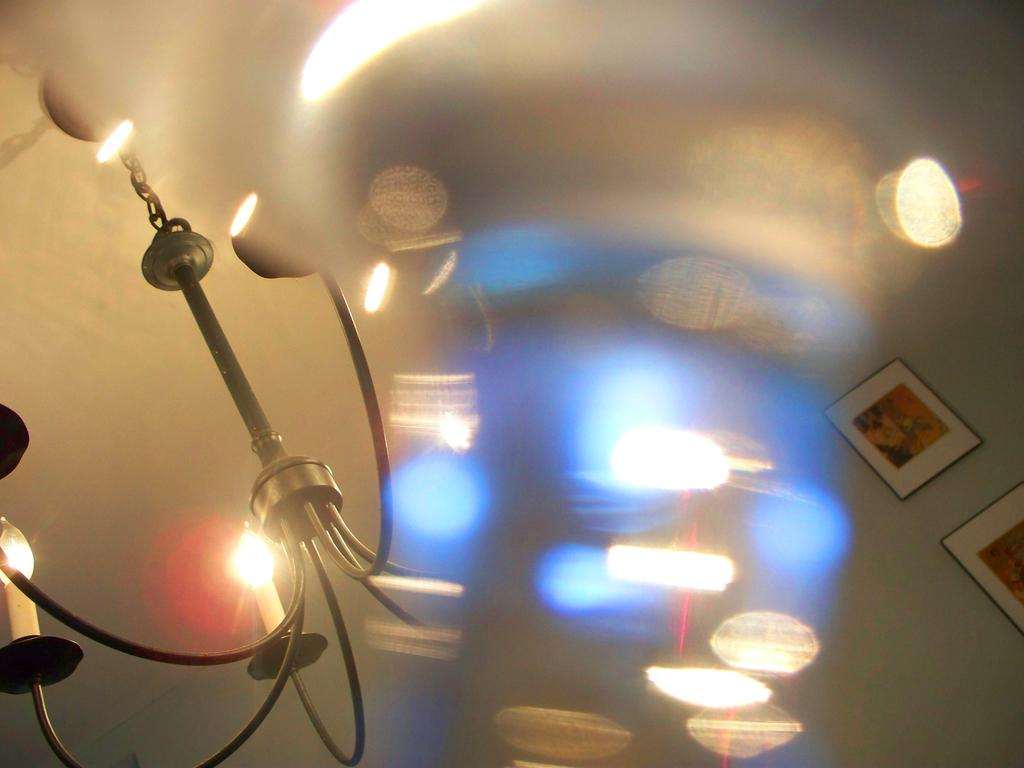What can be seen in the image that provides illumination? There are lights in the image. What is attached to the wall in the image? There are photos attached to the wall in the image. What other objects can be seen in the image besides lights and photos? There are other objects in the image. Where is the yam located in the image? There is no yam present in the image. Is there a playground visible in the image? There is no playground present in the image. What is the chance of winning a prize in the image? The image does not depict any game or contest, so there is no chance of winning a prize. 